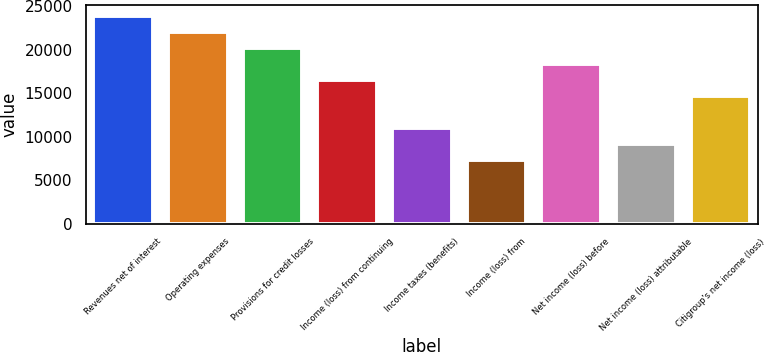<chart> <loc_0><loc_0><loc_500><loc_500><bar_chart><fcel>Revenues net of interest<fcel>Operating expenses<fcel>Provisions for credit losses<fcel>Income (loss) from continuing<fcel>Income taxes (benefits)<fcel>Income (loss) from<fcel>Net income (loss) before<fcel>Net income (loss) attributable<fcel>Citigroup's net income (loss)<nl><fcel>23882.3<fcel>22045.2<fcel>20208.1<fcel>16533.9<fcel>11022.6<fcel>7348.44<fcel>18371<fcel>9185.54<fcel>14696.8<nl></chart> 